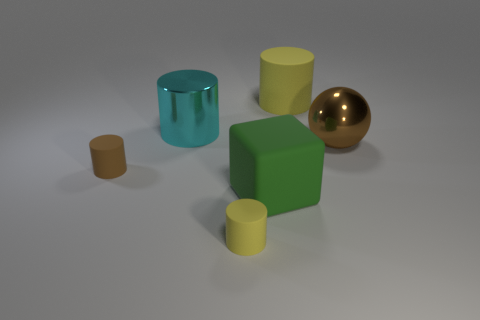Subtract all purple cylinders. Subtract all purple balls. How many cylinders are left? 4 Add 1 big cylinders. How many objects exist? 7 Subtract all cylinders. How many objects are left? 2 Subtract all brown shiny balls. Subtract all brown matte cylinders. How many objects are left? 4 Add 2 tiny matte cylinders. How many tiny matte cylinders are left? 4 Add 5 metallic cylinders. How many metallic cylinders exist? 6 Subtract 0 purple cubes. How many objects are left? 6 